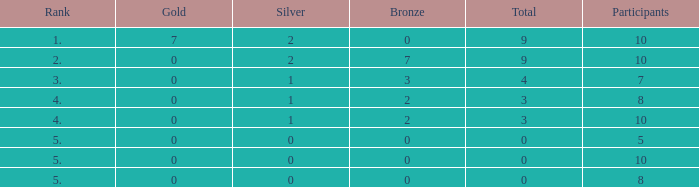What is the total number of Participants that has Silver that's smaller than 0? None. 